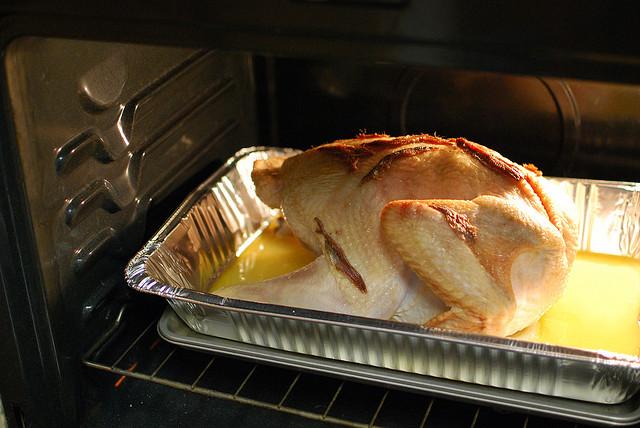Is the oven on?
Short answer required. Yes. What color is the pan?
Write a very short answer. Silver. What type of meat is being cooked?
Give a very brief answer. Chicken. 